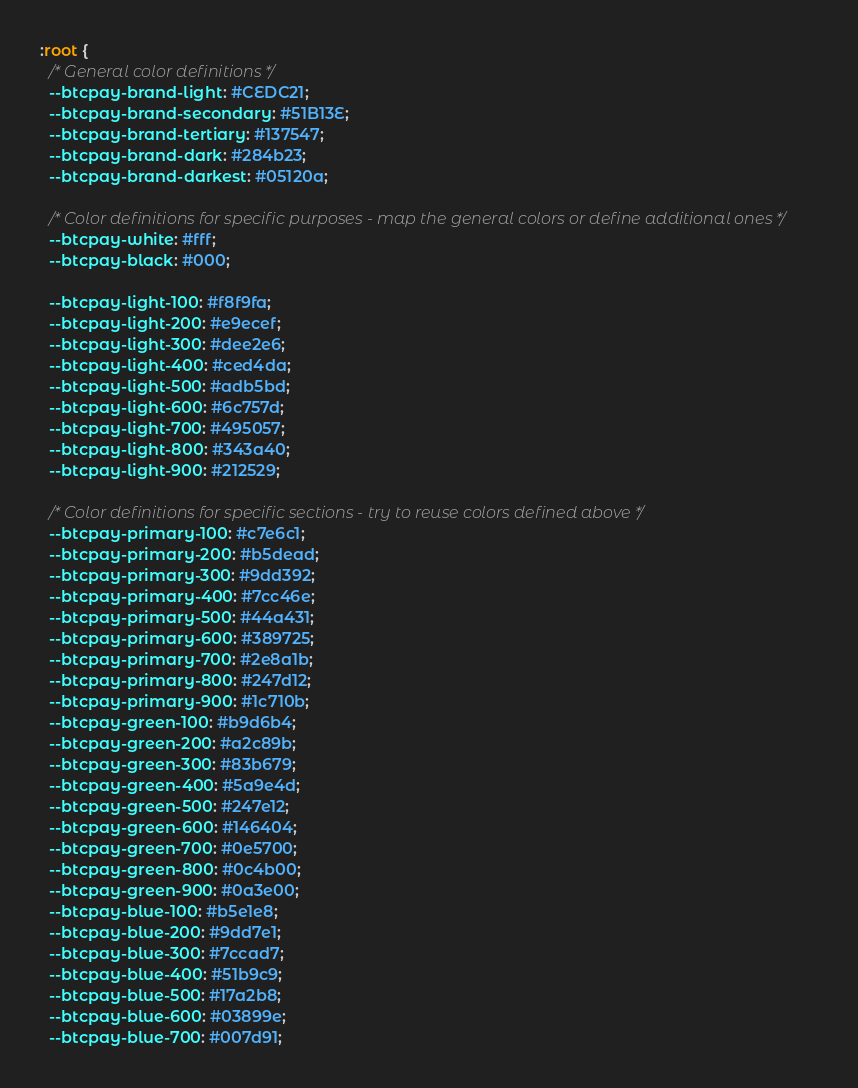<code> <loc_0><loc_0><loc_500><loc_500><_CSS_>:root {
  /* General color definitions */
  --btcpay-brand-light: #CEDC21;
  --btcpay-brand-secondary: #51B13E;
  --btcpay-brand-tertiary: #137547;
  --btcpay-brand-dark: #284b23;
  --btcpay-brand-darkest: #05120a;

  /* Color definitions for specific purposes - map the general colors or define additional ones */
  --btcpay-white: #fff;
  --btcpay-black: #000;

  --btcpay-light-100: #f8f9fa;
  --btcpay-light-200: #e9ecef;
  --btcpay-light-300: #dee2e6;
  --btcpay-light-400: #ced4da;
  --btcpay-light-500: #adb5bd;
  --btcpay-light-600: #6c757d;
  --btcpay-light-700: #495057;
  --btcpay-light-800: #343a40;
  --btcpay-light-900: #212529;

  /* Color definitions for specific sections - try to reuse colors defined above */
  --btcpay-primary-100: #c7e6c1;
  --btcpay-primary-200: #b5dead;
  --btcpay-primary-300: #9dd392;
  --btcpay-primary-400: #7cc46e;
  --btcpay-primary-500: #44a431;
  --btcpay-primary-600: #389725;
  --btcpay-primary-700: #2e8a1b;
  --btcpay-primary-800: #247d12;
  --btcpay-primary-900: #1c710b;
  --btcpay-green-100: #b9d6b4;
  --btcpay-green-200: #a2c89b;
  --btcpay-green-300: #83b679;
  --btcpay-green-400: #5a9e4d;
  --btcpay-green-500: #247e12;
  --btcpay-green-600: #146404;
  --btcpay-green-700: #0e5700;
  --btcpay-green-800: #0c4b00;
  --btcpay-green-900: #0a3e00;
  --btcpay-blue-100: #b5e1e8;
  --btcpay-blue-200: #9dd7e1;
  --btcpay-blue-300: #7ccad7;
  --btcpay-blue-400: #51b9c9;
  --btcpay-blue-500: #17a2b8;
  --btcpay-blue-600: #03899e;
  --btcpay-blue-700: #007d91;</code> 